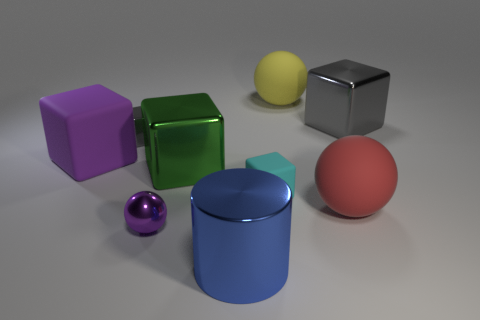What number of big rubber things are the same color as the tiny shiny ball? There is one large rubber object—a green cube—that shares the same color as the small shiny sphere. 